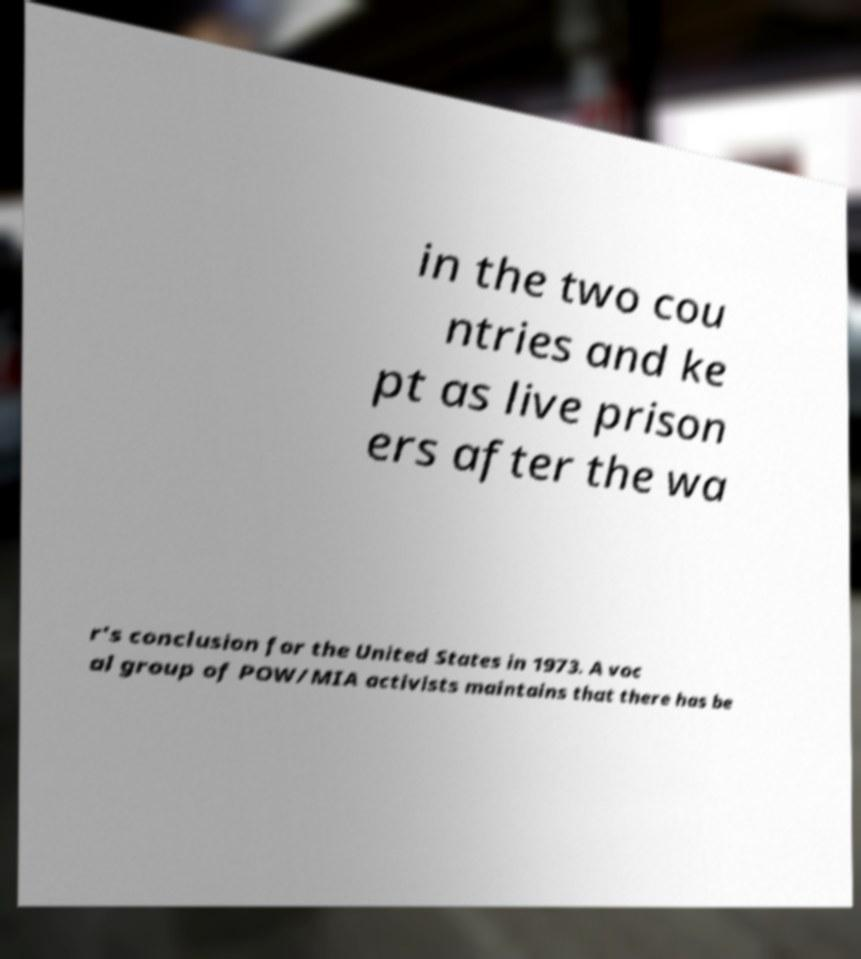Could you extract and type out the text from this image? in the two cou ntries and ke pt as live prison ers after the wa r's conclusion for the United States in 1973. A voc al group of POW/MIA activists maintains that there has be 